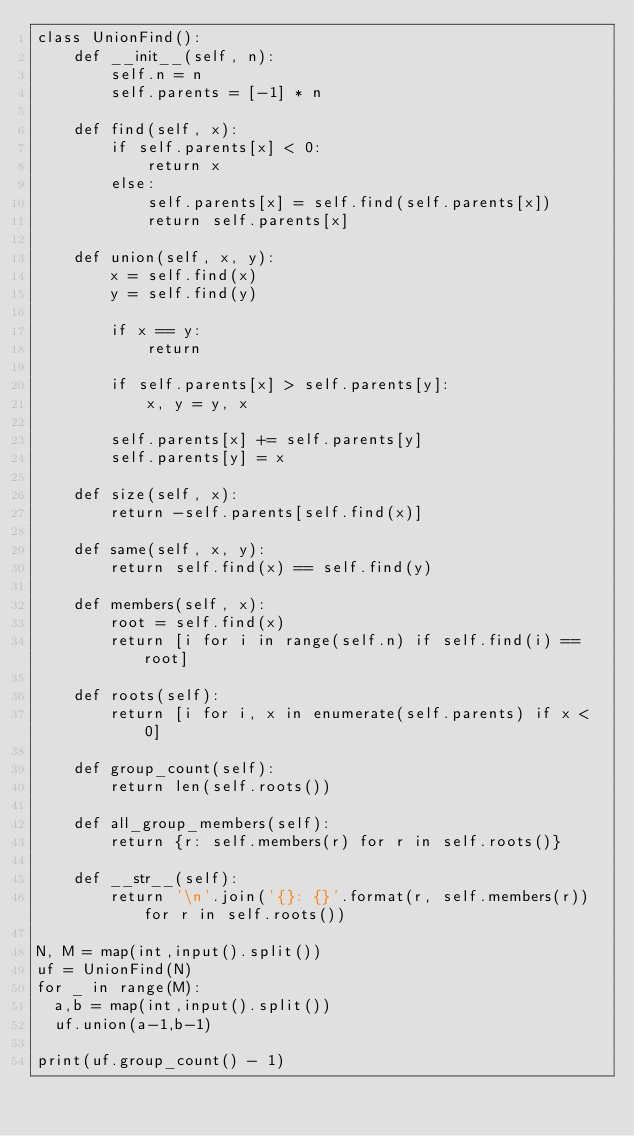<code> <loc_0><loc_0><loc_500><loc_500><_Python_>class UnionFind():
    def __init__(self, n):
        self.n = n
        self.parents = [-1] * n

    def find(self, x):
        if self.parents[x] < 0:
            return x
        else:
            self.parents[x] = self.find(self.parents[x])
            return self.parents[x]

    def union(self, x, y):
        x = self.find(x)
        y = self.find(y)

        if x == y:
            return

        if self.parents[x] > self.parents[y]:
            x, y = y, x

        self.parents[x] += self.parents[y]
        self.parents[y] = x

    def size(self, x):
        return -self.parents[self.find(x)]

    def same(self, x, y):
        return self.find(x) == self.find(y)

    def members(self, x):
        root = self.find(x)
        return [i for i in range(self.n) if self.find(i) == root]

    def roots(self):
        return [i for i, x in enumerate(self.parents) if x < 0]

    def group_count(self):
        return len(self.roots())

    def all_group_members(self):
        return {r: self.members(r) for r in self.roots()}

    def __str__(self):
        return '\n'.join('{}: {}'.format(r, self.members(r)) for r in self.roots())
      
N, M = map(int,input().split())
uf = UnionFind(N)
for _ in range(M):
  a,b = map(int,input().split())
  uf.union(a-1,b-1)
  
print(uf.group_count() - 1)</code> 